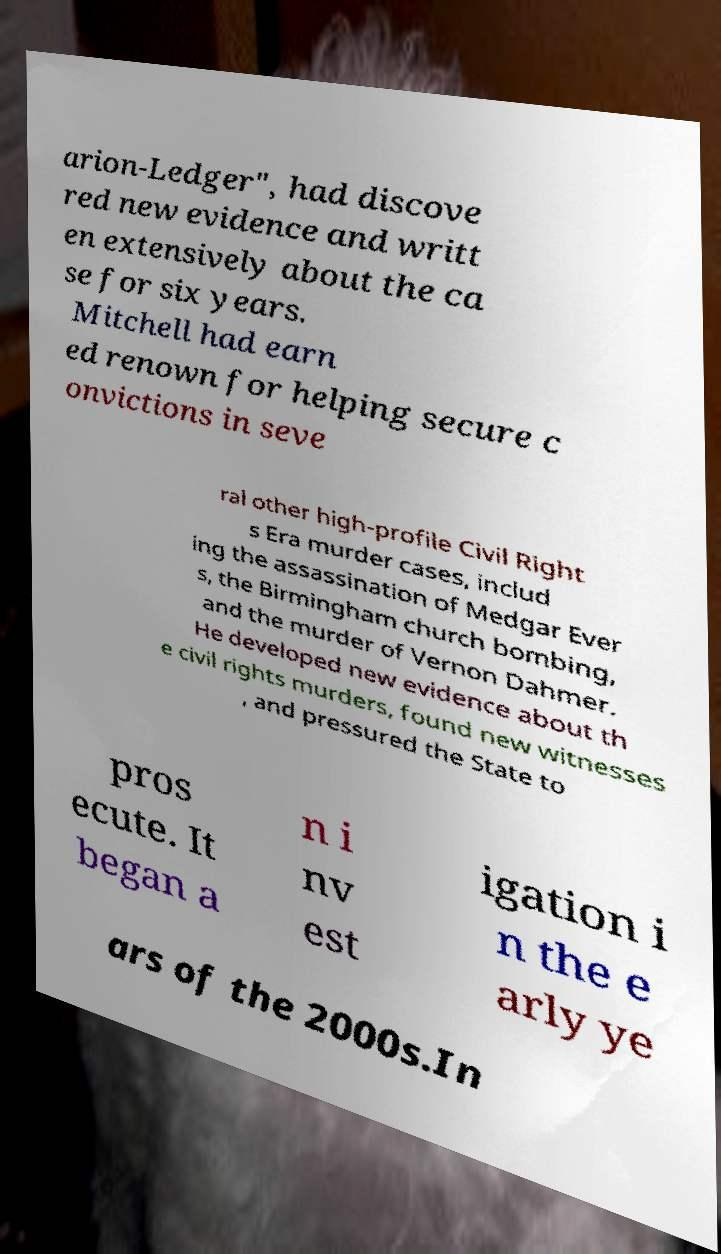Please identify and transcribe the text found in this image. arion-Ledger", had discove red new evidence and writt en extensively about the ca se for six years. Mitchell had earn ed renown for helping secure c onvictions in seve ral other high-profile Civil Right s Era murder cases, includ ing the assassination of Medgar Ever s, the Birmingham church bombing, and the murder of Vernon Dahmer. He developed new evidence about th e civil rights murders, found new witnesses , and pressured the State to pros ecute. It began a n i nv est igation i n the e arly ye ars of the 2000s.In 